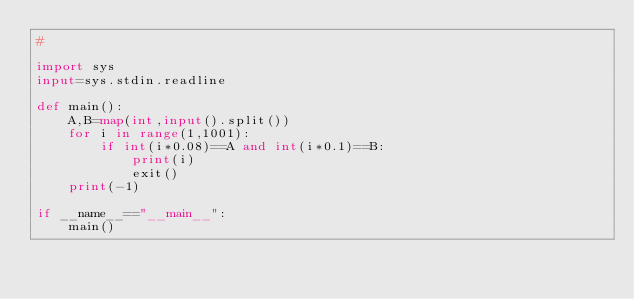Convert code to text. <code><loc_0><loc_0><loc_500><loc_500><_Python_>#

import sys
input=sys.stdin.readline

def main():
    A,B=map(int,input().split())
    for i in range(1,1001):
        if int(i*0.08)==A and int(i*0.1)==B:
            print(i)
            exit()
    print(-1)
    
if __name__=="__main__":
    main()
</code> 